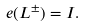<formula> <loc_0><loc_0><loc_500><loc_500>e ( L ^ { \pm } ) = I .</formula> 